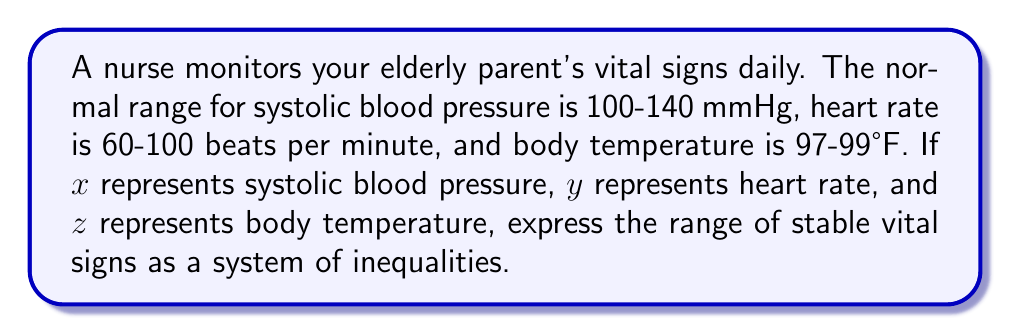Give your solution to this math problem. To express the range of stable vital signs as a system of inequalities, we need to translate the given information into mathematical notation:

1. Systolic blood pressure ($x$):
   Lower bound: $x \geq 100$
   Upper bound: $x \leq 140$

2. Heart rate ($y$):
   Lower bound: $y \geq 60$
   Upper bound: $y \leq 100$

3. Body temperature ($z$):
   Lower bound: $z \geq 97$
   Upper bound: $z \leq 99$

Combining these inequalities, we get a system that represents the range of stable vital signs:

$$
\begin{cases}
100 \leq x \leq 140 \\
60 \leq y \leq 100 \\
97 \leq z \leq 99
\end{cases}
$$

This system of inequalities defines a three-dimensional region in which all stable vital sign combinations lie.
Answer: $$
\begin{cases}
100 \leq x \leq 140 \\
60 \leq y \leq 100 \\
97 \leq z \leq 99
\end{cases}
$$ 